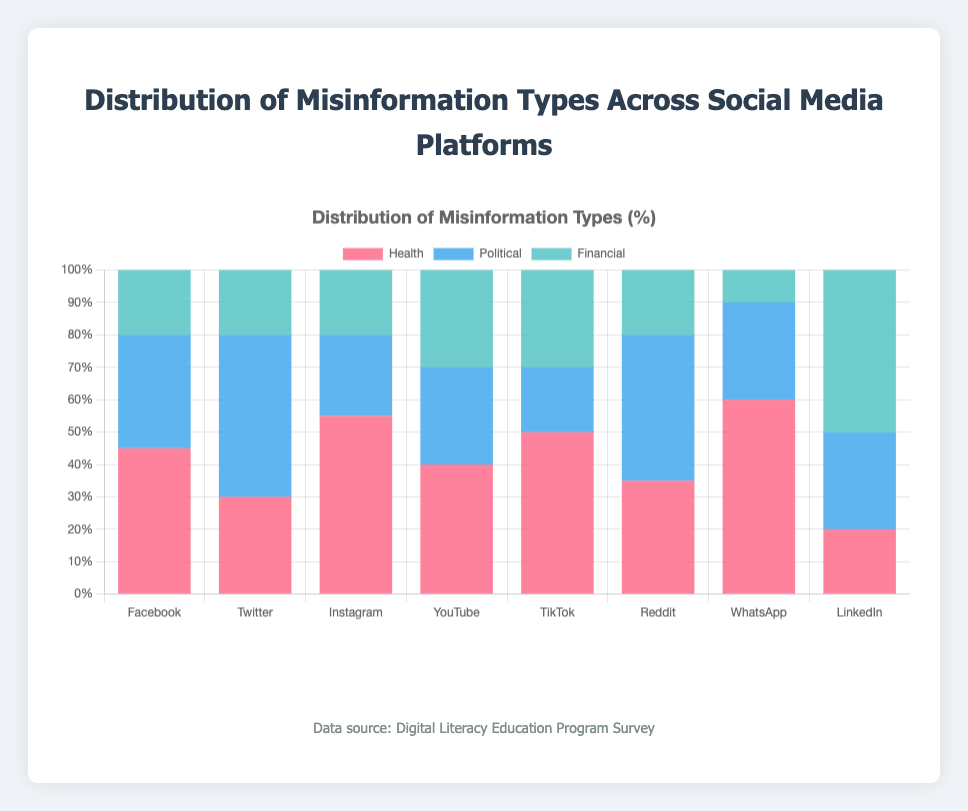Which social media platform has the highest percentage of health misinformation? The platform is the one with the tallest red section in the stacked bar. From the chart, WhatsApp has the highest red segment.
Answer: WhatsApp Which type of misinformation is the least common on YouTube? Look at the heights of the different colored sections in the YouTube bar. The smallest section is the blue one, representing political misinformation.
Answer: Political What is the total percentage of financial misinformation across all platforms? Sum the heights of the green sections in all bars: 20 + 20 + 20 + 30 + 30 + 20 + 10 + 50 = 200. 200/8 platforms = 25%
Answer: 25% Compare the percentage of political misinformation between Facebook and Reddit. Which platform has more, and by how much? Facebook has 35% (blue section), and Reddit has 45% (blue section). 45% - 35% = 10%.
Answer: Reddit by 10% What is the percentage difference in health misinformation between Instagram and LinkedIn? Instagram has 55% (red section), while LinkedIn has 20% (red section). 55% - 20% = 35%.
Answer: 35% 